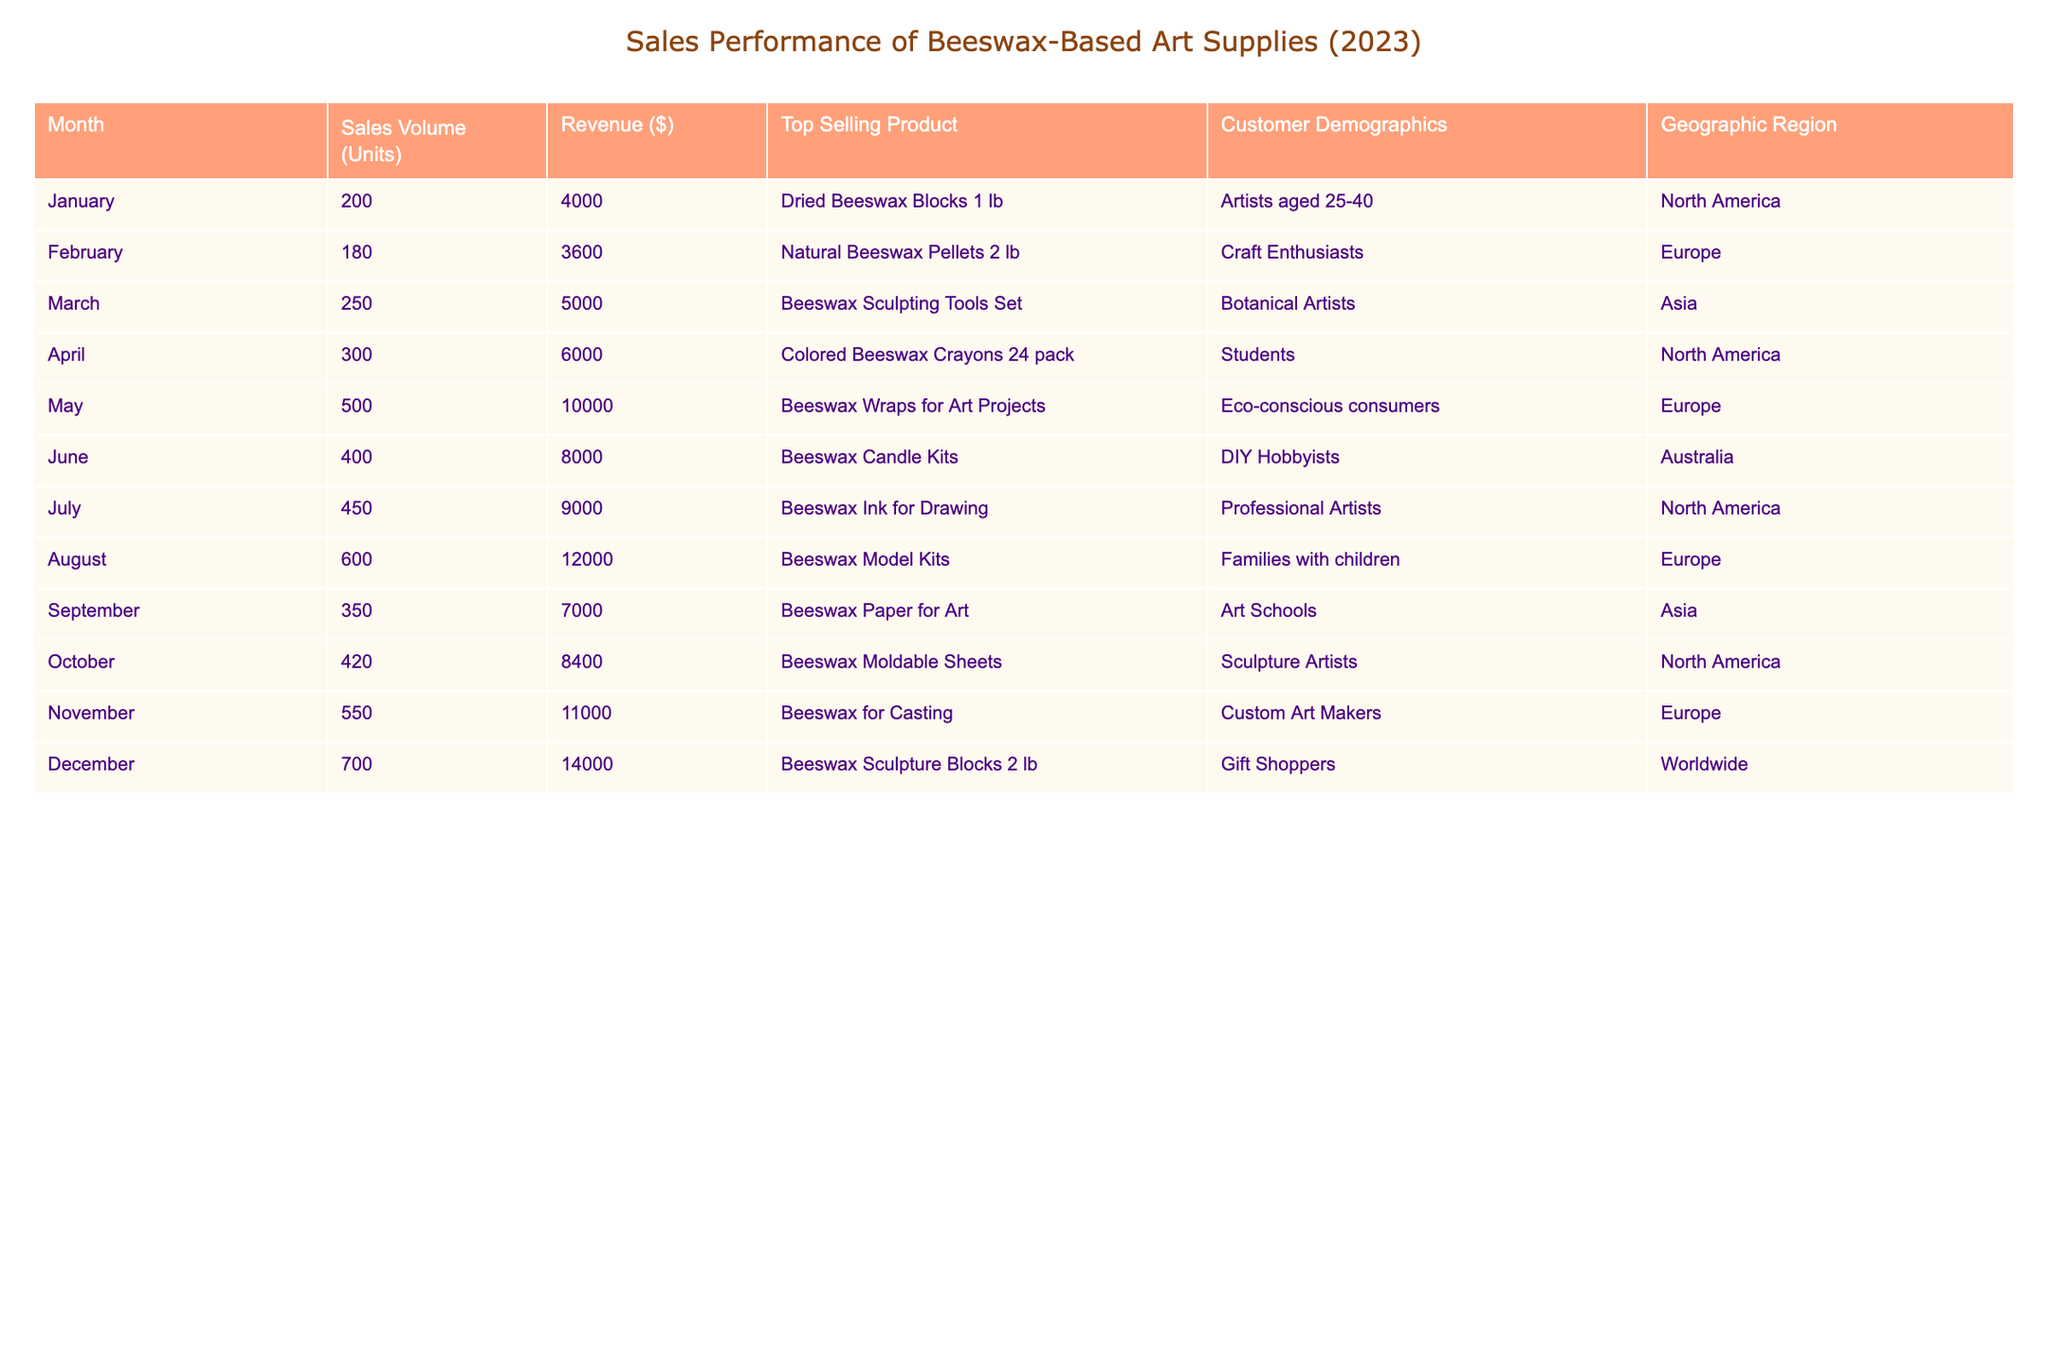What was the top-selling product in December? The table shows that the top-selling product in December was "Beeswax Sculpture Blocks 2 lb."
Answer: Beeswax Sculpture Blocks 2 lb Which month had the highest sales volume? The highest sales volume recorded in the table was 700 units in December.
Answer: December What is the total revenue from March to May? The individual revenues from March ($5000), April ($6000), and May ($10000) sum up to $5000 + $6000 + $10000 = $21000.
Answer: $21000 Did sales volume increase from January to February? In January, the sales volume was 200 units, while in February it was 180 units, indicating a decrease.
Answer: No What is the average revenue per month for the year? The total revenue for the year can be calculated by summing all monthly revenues ($4000 + $3600 + $5000 + $6000 + $10000 + $8000 + $9000 + $12000 + $7000 + $8400 + $11000 + $14000 = $69400) and dividing by the number of months (12). Thus, the average revenue per month is $69400 / 12 = $5783.33.
Answer: $5783.33 Which geographic region had the highest sales in November? November's sales data indicates that Europe had the highest sales with 550 units sold.
Answer: Europe How much revenue was generated by DIY Hobbyists in June? The table indicates that DIY Hobbyists generated $8000 in revenue from the sale of Beeswax Candle Kits in June.
Answer: $8000 What was the difference in sales volume between the months of August and September? August had sales volume of 600 units while September had 350 units. The difference is 600 - 350 = 250 units.
Answer: 250 units Which customer demographic bought the most products in October? According to the table, the customer demographic in October was Sculpture Artists who purchased a total of 420 units.
Answer: Sculpture Artists What was the total number of units sold from January to October? Adding the sales volumes from January (200), February (180), March (250), April (300), May (500), June (400), July (450), August (600), September (350), and October (420) results in a total of 200 + 180 + 250 + 300 + 500 + 400 + 450 + 600 + 350 + 420 = 4150 units.
Answer: 4150 units What percentage of total revenue is derived from the top-selling product in December? The total revenue in December was $14000 and the top-selling product's revenue in December, which is also part of the total, means that the percentage calculation is ($14000 / $69400) * 100 = 20.19%.
Answer: 20.19% 